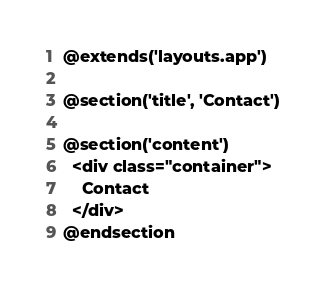Convert code to text. <code><loc_0><loc_0><loc_500><loc_500><_PHP_>@extends('layouts.app')

@section('title', 'Contact')

@section('content')
  <div class="container">
    Contact
  </div>
@endsection</code> 